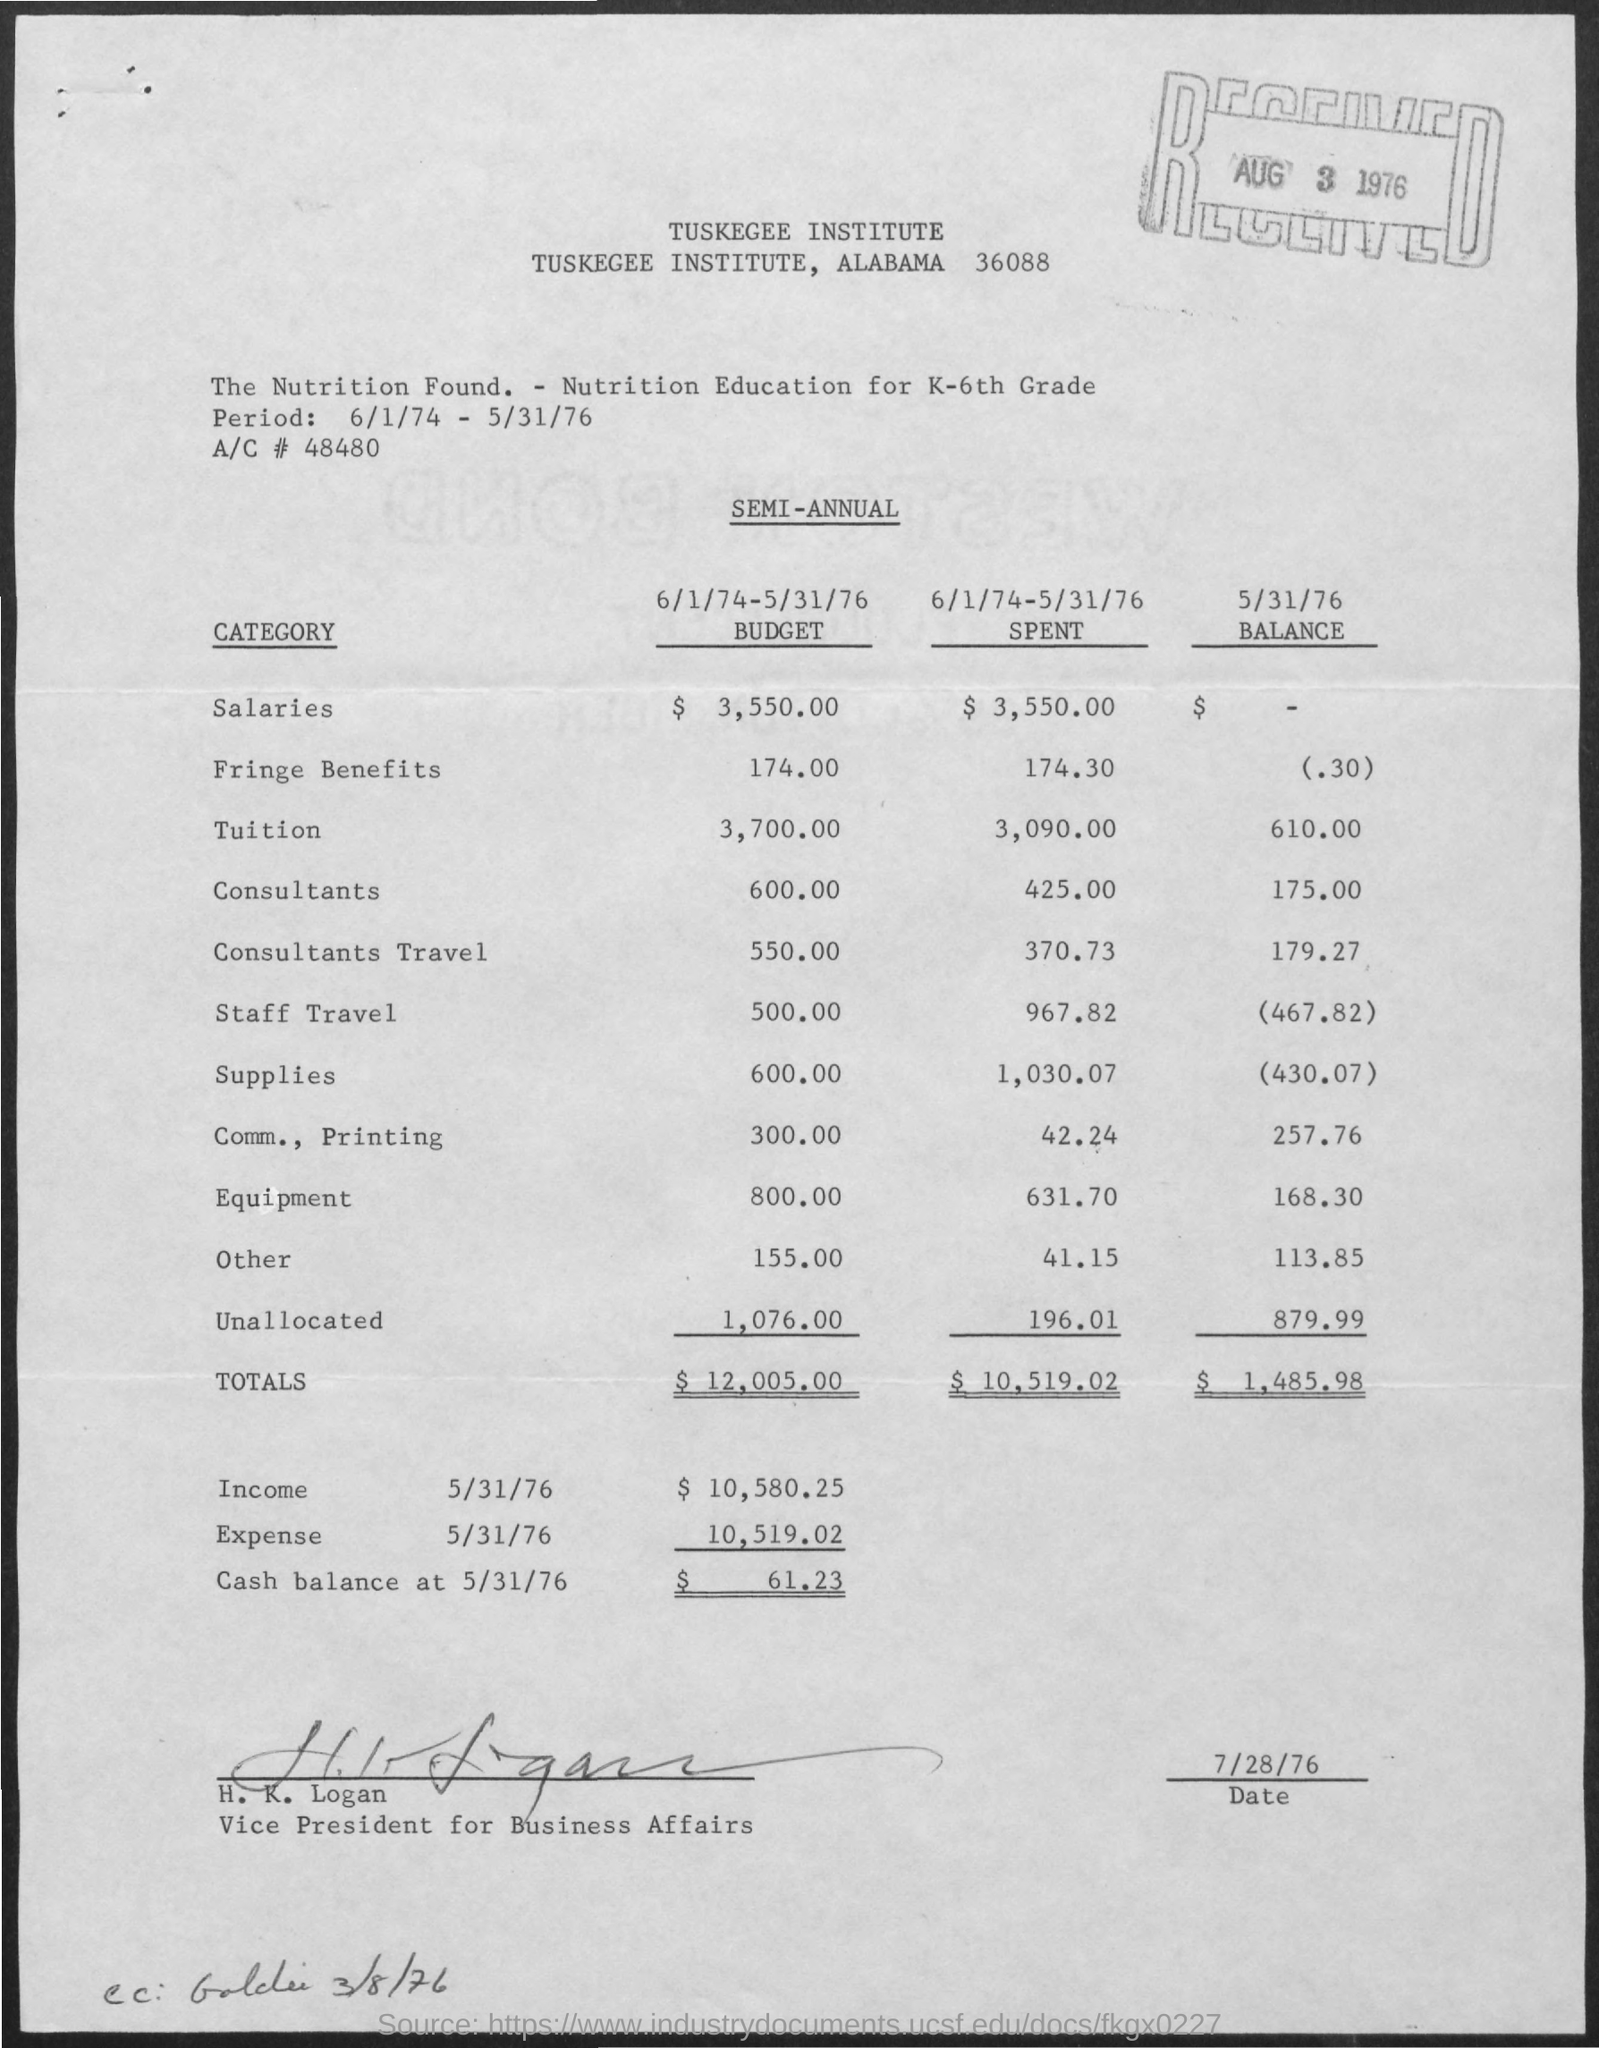Identify some key points in this picture. The balance amount in consultants is 175.00. The document was signed by H.K Logan. The period between 6/1/74 and 5/31/76 is referred to as 'What is the "period"?'. The cash balance on May 31st, 1976 was $61.23. The budget allocated for fringe benefits is 174.00. 